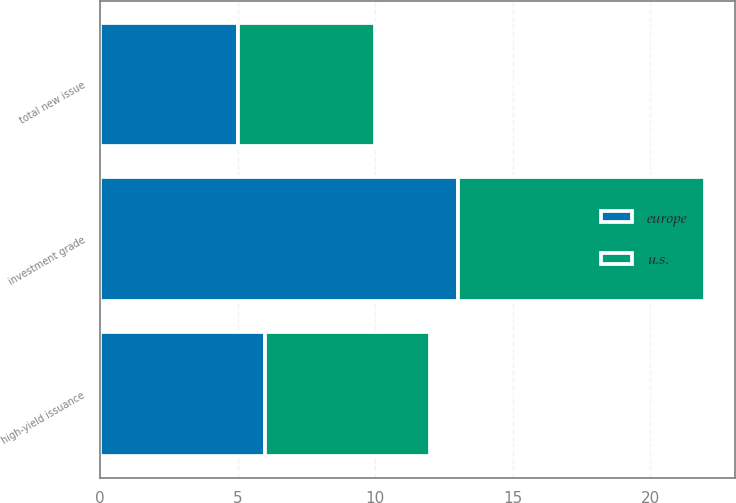<chart> <loc_0><loc_0><loc_500><loc_500><stacked_bar_chart><ecel><fcel>high-yield issuance<fcel>investment grade<fcel>total new issue<nl><fcel>u.s.<fcel>6<fcel>9<fcel>5<nl><fcel>europe<fcel>6<fcel>13<fcel>5<nl></chart> 